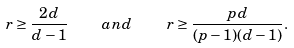<formula> <loc_0><loc_0><loc_500><loc_500>r \geq \frac { 2 d } { d - 1 } \quad a n d \quad r \geq \frac { p d } { ( p - 1 ) ( d - 1 ) } .</formula> 